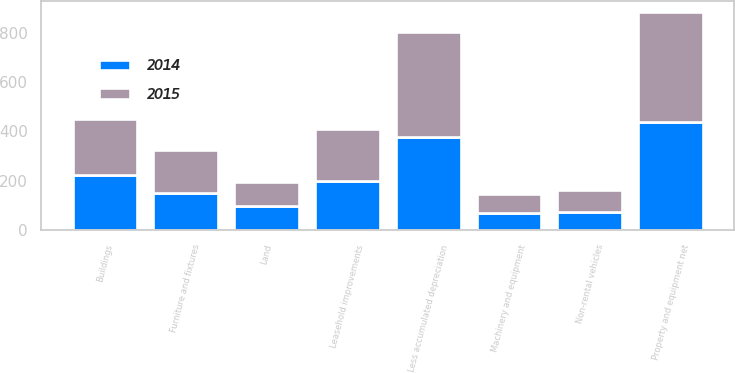Convert chart to OTSL. <chart><loc_0><loc_0><loc_500><loc_500><stacked_bar_chart><ecel><fcel>Land<fcel>Buildings<fcel>Non-rental vehicles<fcel>Machinery and equipment<fcel>Furniture and fixtures<fcel>Leasehold improvements<fcel>Less accumulated depreciation<fcel>Property and equipment net<nl><fcel>2015<fcel>98<fcel>226<fcel>86<fcel>78<fcel>171<fcel>212<fcel>426<fcel>445<nl><fcel>2014<fcel>97<fcel>223<fcel>75<fcel>68<fcel>152<fcel>200<fcel>377<fcel>438<nl></chart> 